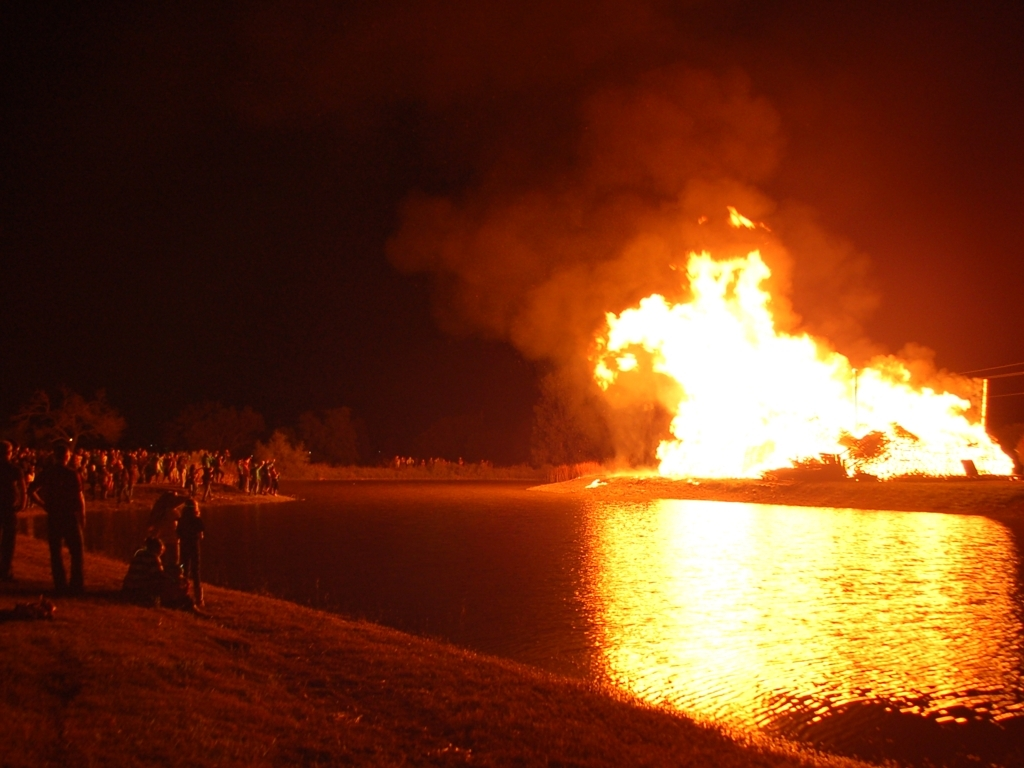Could this image have any significance or typical use? This image might be used for various purposes such as illustrating articles on cultural events involving bonfires, discussing fire safety measures, or even representing concepts like 'heat' or 'light' in educational materials. Its dramatic nature could also serve well in creative projects that call for impactful visuals. 